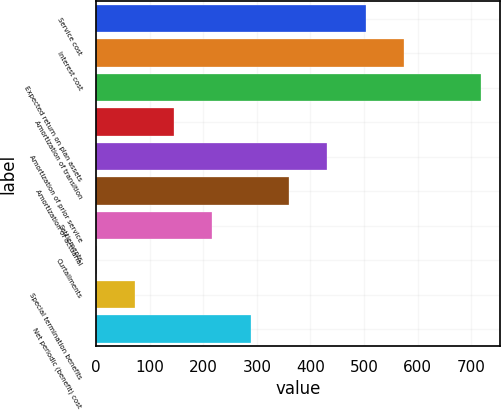Convert chart to OTSL. <chart><loc_0><loc_0><loc_500><loc_500><bar_chart><fcel>Service cost<fcel>Interest cost<fcel>Expected return on plan assets<fcel>Amortization of transition<fcel>Amortization of prior service<fcel>Amortization of actuarial<fcel>Settlements<fcel>Curtailments<fcel>Special termination benefits<fcel>Net periodic (benefit) cost<nl><fcel>503.26<fcel>574.85<fcel>718<fcel>145.31<fcel>431.67<fcel>360.08<fcel>216.9<fcel>2.13<fcel>73.72<fcel>288.49<nl></chart> 